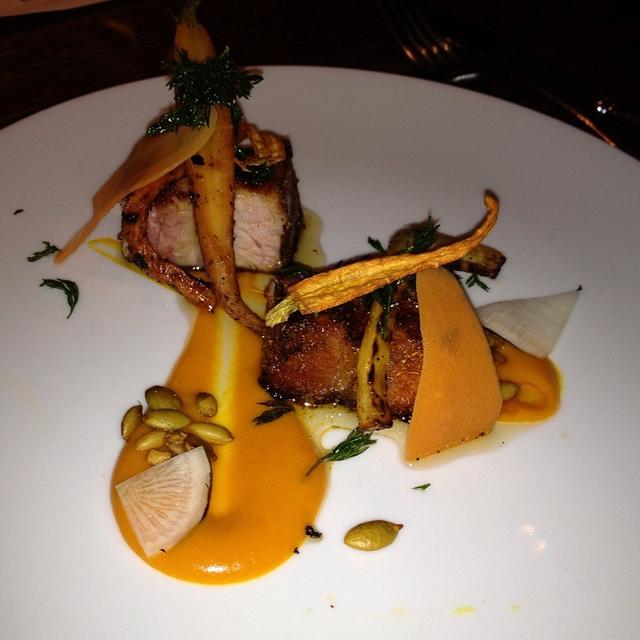What color is the plate?
Write a very short answer. White. Is this from a fast food restaurant?
Keep it brief. No. Does this food look healthy?
Quick response, please. Yes. 